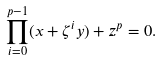Convert formula to latex. <formula><loc_0><loc_0><loc_500><loc_500>\prod _ { i = 0 } ^ { p - 1 } ( x + \zeta ^ { i } y ) + z ^ { p } = 0 .</formula> 